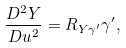<formula> <loc_0><loc_0><loc_500><loc_500>\frac { D ^ { 2 } Y } { D u ^ { 2 } } = R _ { Y \gamma ^ { \prime } } \gamma ^ { \prime } ,</formula> 